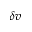<formula> <loc_0><loc_0><loc_500><loc_500>\delta v</formula> 